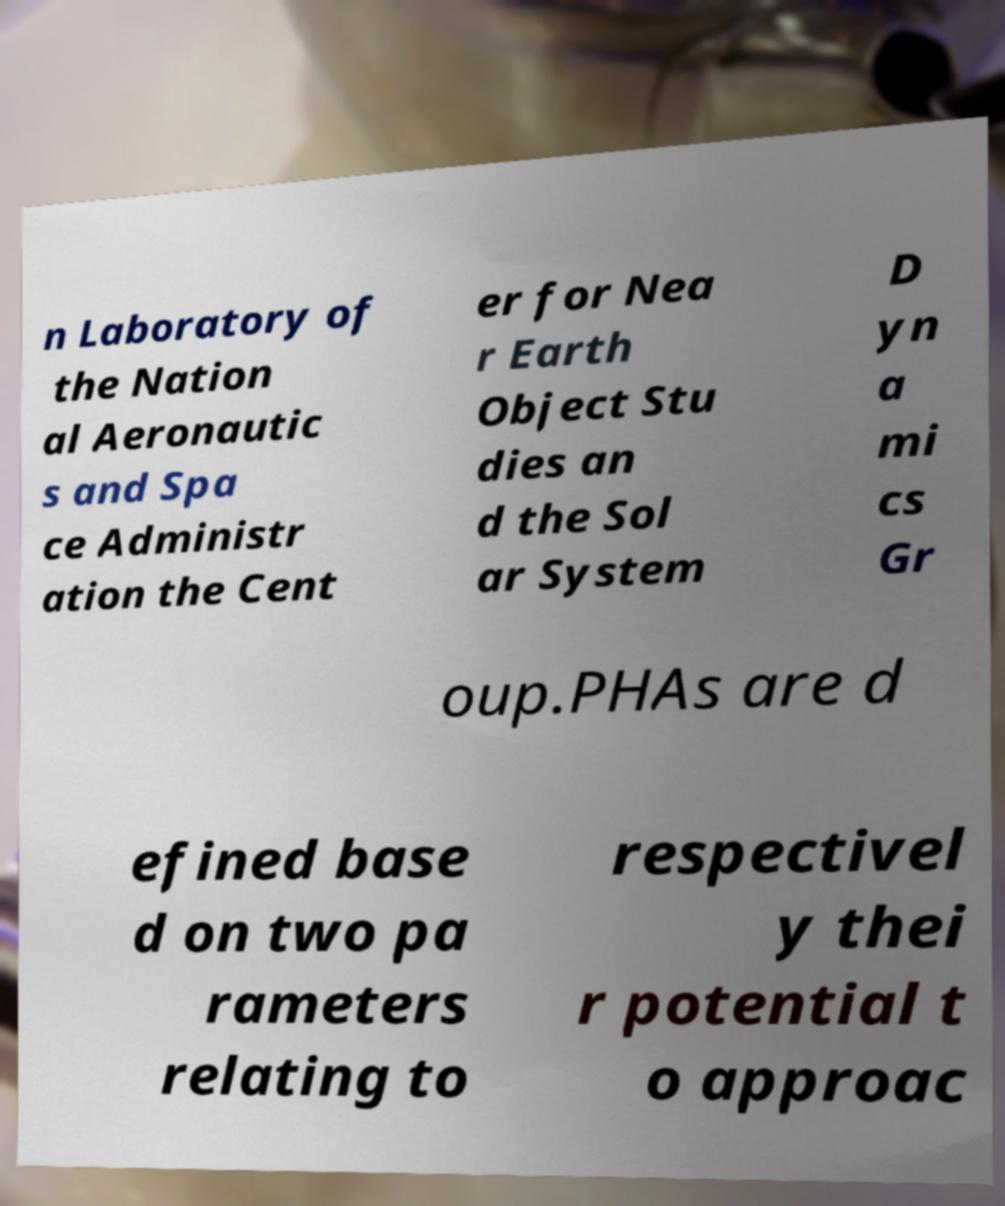There's text embedded in this image that I need extracted. Can you transcribe it verbatim? n Laboratory of the Nation al Aeronautic s and Spa ce Administr ation the Cent er for Nea r Earth Object Stu dies an d the Sol ar System D yn a mi cs Gr oup.PHAs are d efined base d on two pa rameters relating to respectivel y thei r potential t o approac 